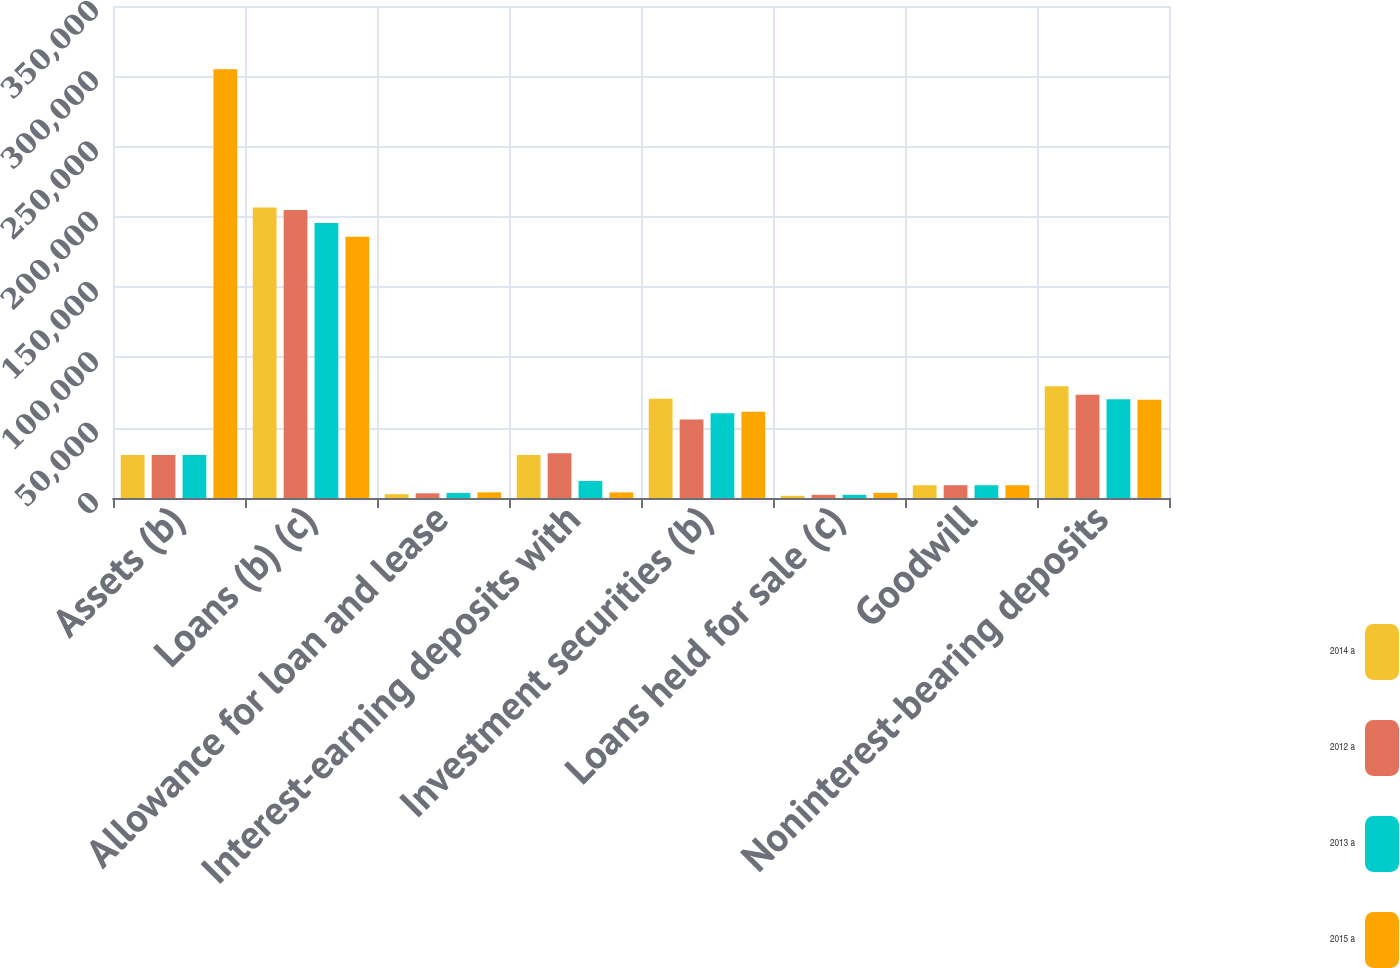Convert chart to OTSL. <chart><loc_0><loc_0><loc_500><loc_500><stacked_bar_chart><ecel><fcel>Assets (b)<fcel>Loans (b) (c)<fcel>Allowance for loan and lease<fcel>Interest-earning deposits with<fcel>Investment securities (b)<fcel>Loans held for sale (c)<fcel>Goodwill<fcel>Noninterest-bearing deposits<nl><fcel>2014 a<fcel>30546<fcel>206696<fcel>2727<fcel>30546<fcel>70528<fcel>1540<fcel>9103<fcel>79435<nl><fcel>2012 a<fcel>30546<fcel>204817<fcel>3331<fcel>31779<fcel>55823<fcel>2262<fcel>9103<fcel>73479<nl><fcel>2013 a<fcel>30546<fcel>195613<fcel>3609<fcel>12135<fcel>60294<fcel>2255<fcel>9074<fcel>70306<nl><fcel>2015 a<fcel>305029<fcel>185856<fcel>4036<fcel>3984<fcel>61406<fcel>3693<fcel>9072<fcel>69980<nl></chart> 